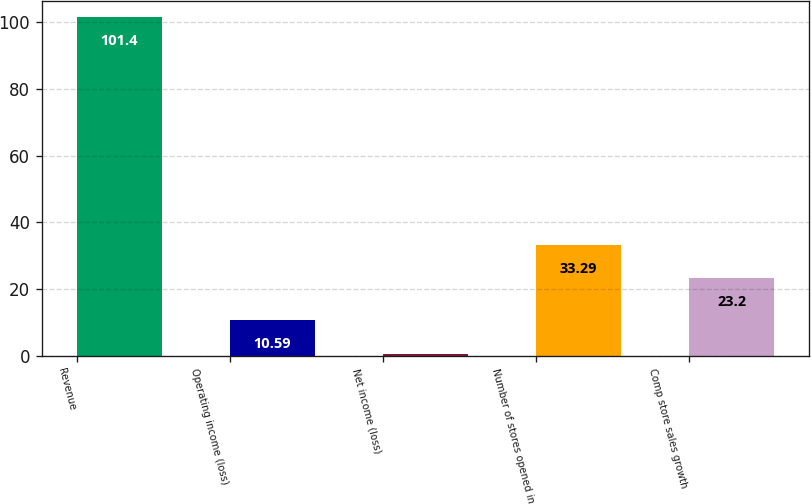<chart> <loc_0><loc_0><loc_500><loc_500><bar_chart><fcel>Revenue<fcel>Operating income (loss)<fcel>Net income (loss)<fcel>Number of stores opened in<fcel>Comp store sales growth<nl><fcel>101.4<fcel>10.59<fcel>0.5<fcel>33.29<fcel>23.2<nl></chart> 